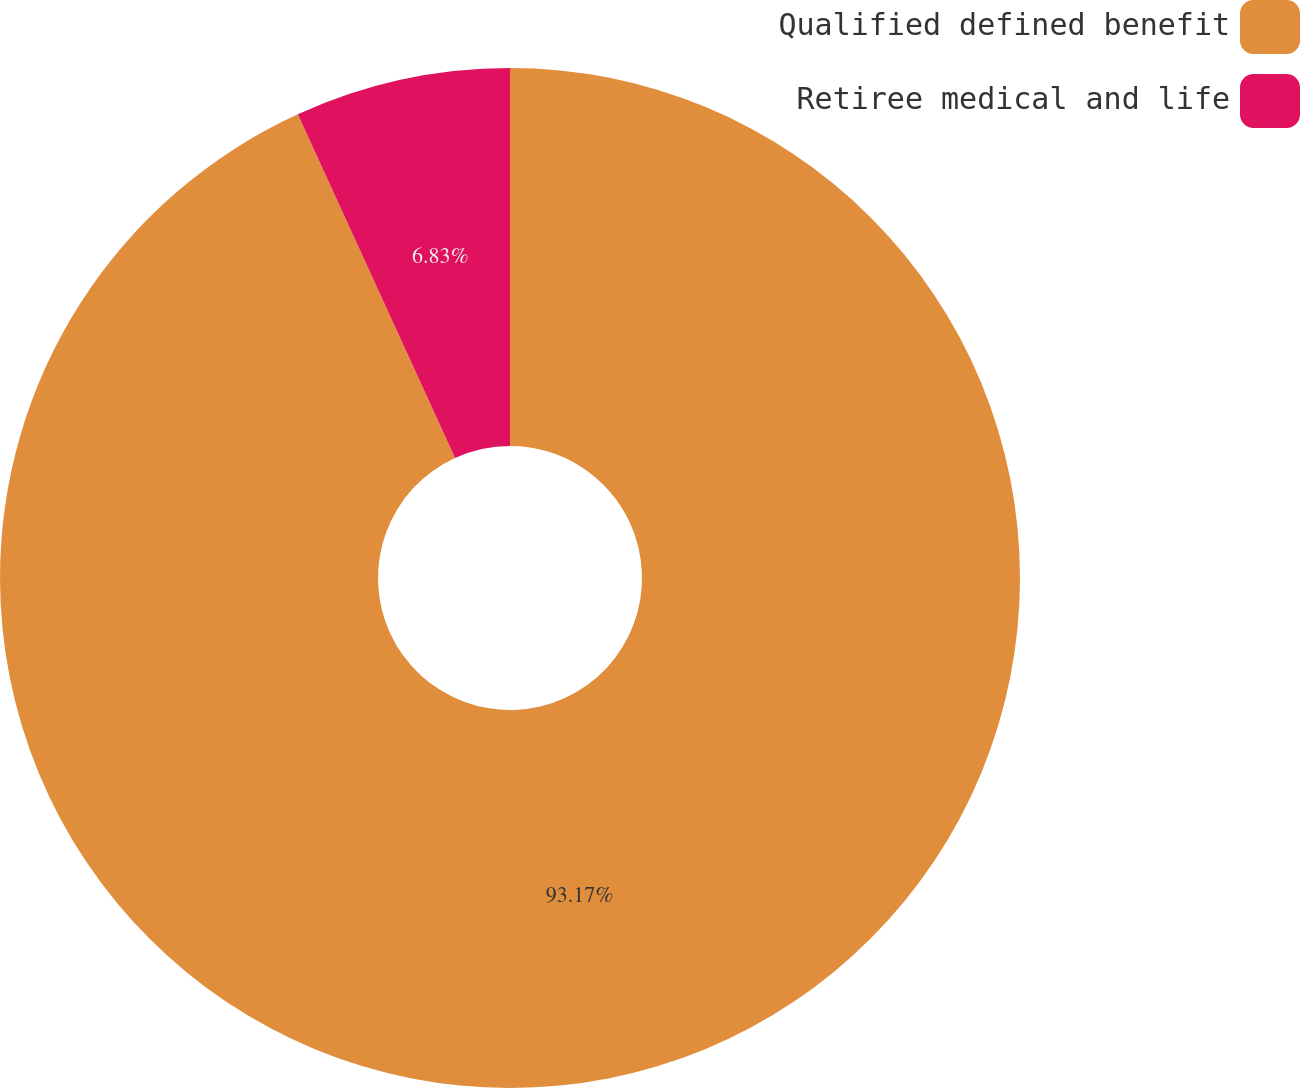Convert chart to OTSL. <chart><loc_0><loc_0><loc_500><loc_500><pie_chart><fcel>Qualified defined benefit<fcel>Retiree medical and life<nl><fcel>93.17%<fcel>6.83%<nl></chart> 